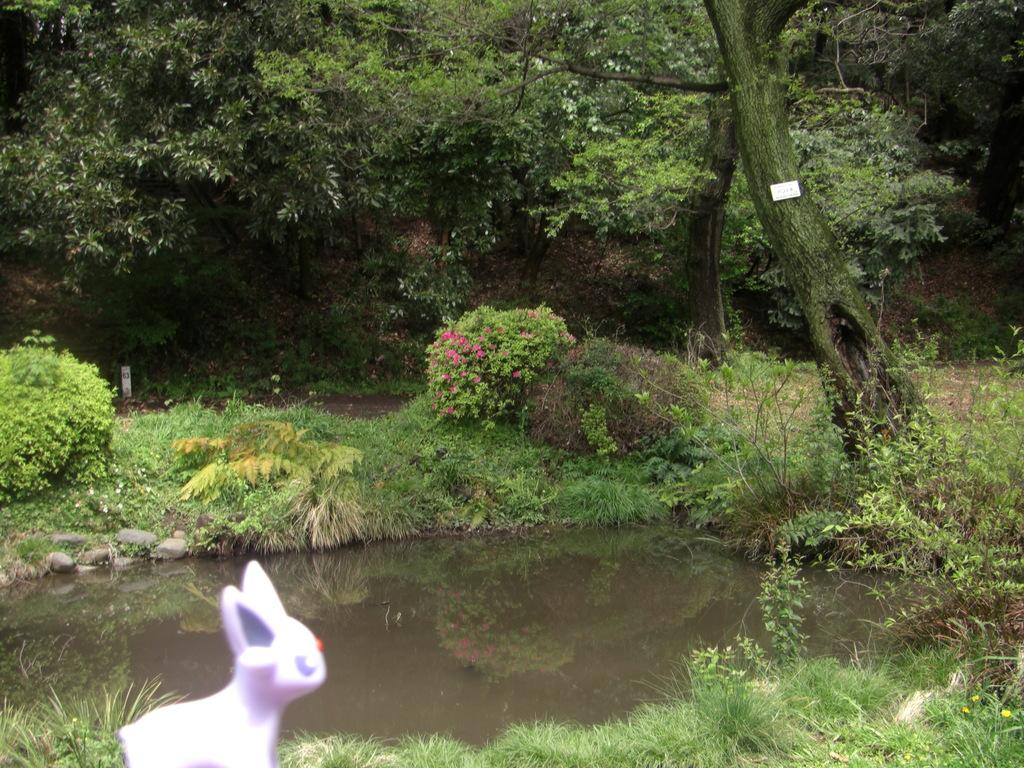What object can be seen in the image that is not a part of the natural environment? There is a toy in the image. What type of natural environment is depicted in the image? The image features grass, water, floral plants, and trees. Can you describe the water in the image? The image contains water, which is likely a part of a natural body of water or a man-made water feature. What type of plants are present in the image? There are floral plants and trees in the image. What type of payment is required to enter the structure in the image? There is no structure or payment mentioned in the image; it features a toy and natural elements. 